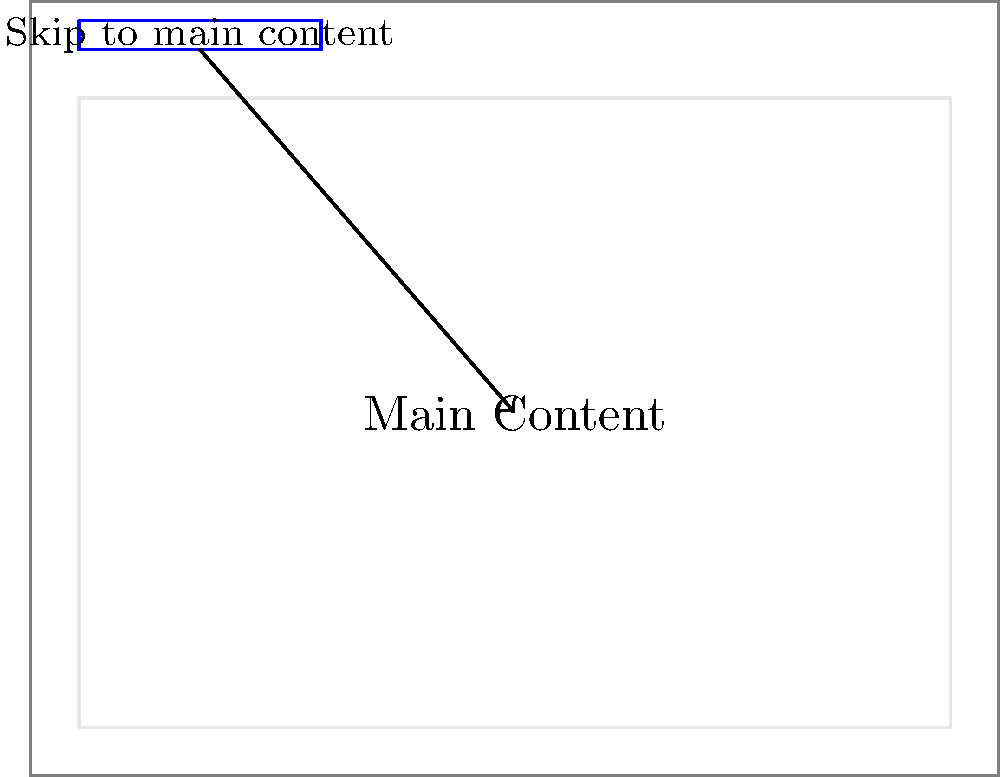In the diagram above, which represents a website layout, what is the primary purpose of the blue box labeled "Skip to main content" at the top of the page, and how should it be implemented to ensure maximum accessibility? 1. Purpose: The blue box represents a skip navigation link, which is an essential accessibility feature for keyboard users and screen reader users.

2. Functionality: It allows users to bypass repetitive navigation menus and jump directly to the main content of the page.

3. Implementation:
   a. HTML structure: Place the skip link as the first focusable element in the HTML, typically right after the opening <body> tag.
   b. CSS styling: Initially hide the link off-screen using CSS (e.g., position: absolute; left: -9999px;).
   c. Focus state: Make the link visible when it receives keyboard focus (e.g., left: 0; top: 0;).

4. Visual representation: As shown in the diagram, the skip link should be visible and clickable when focused, typically appearing at the top of the page.

5. Destination: The skip link should target the main content area of the page, usually with an id attribute (e.g., <main id="main-content">).

6. ARIA attributes: Use aria-label or aria-labelledby to provide a clear description of the link's purpose for screen reader users.

7. Testing: Ensure the skip link works correctly with keyboard navigation and screen readers.

8. Consistency: Implement skip links consistently across all pages of the website.

By implementing skip navigation links correctly, developers can significantly improve the browsing experience for users who rely on keyboard navigation or assistive technologies.
Answer: To provide keyboard users and screen reader users a way to bypass repetitive navigation and access main content quickly. 